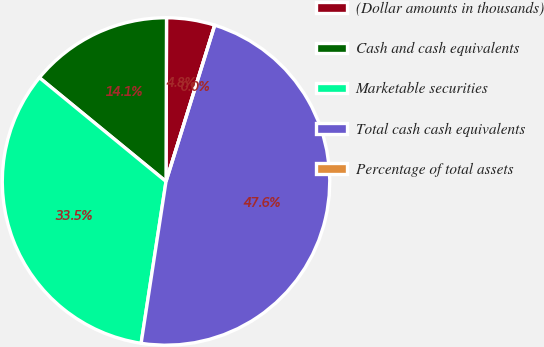Convert chart. <chart><loc_0><loc_0><loc_500><loc_500><pie_chart><fcel>(Dollar amounts in thousands)<fcel>Cash and cash equivalents<fcel>Marketable securities<fcel>Total cash cash equivalents<fcel>Percentage of total assets<nl><fcel>4.76%<fcel>14.12%<fcel>33.5%<fcel>47.62%<fcel>0.0%<nl></chart> 